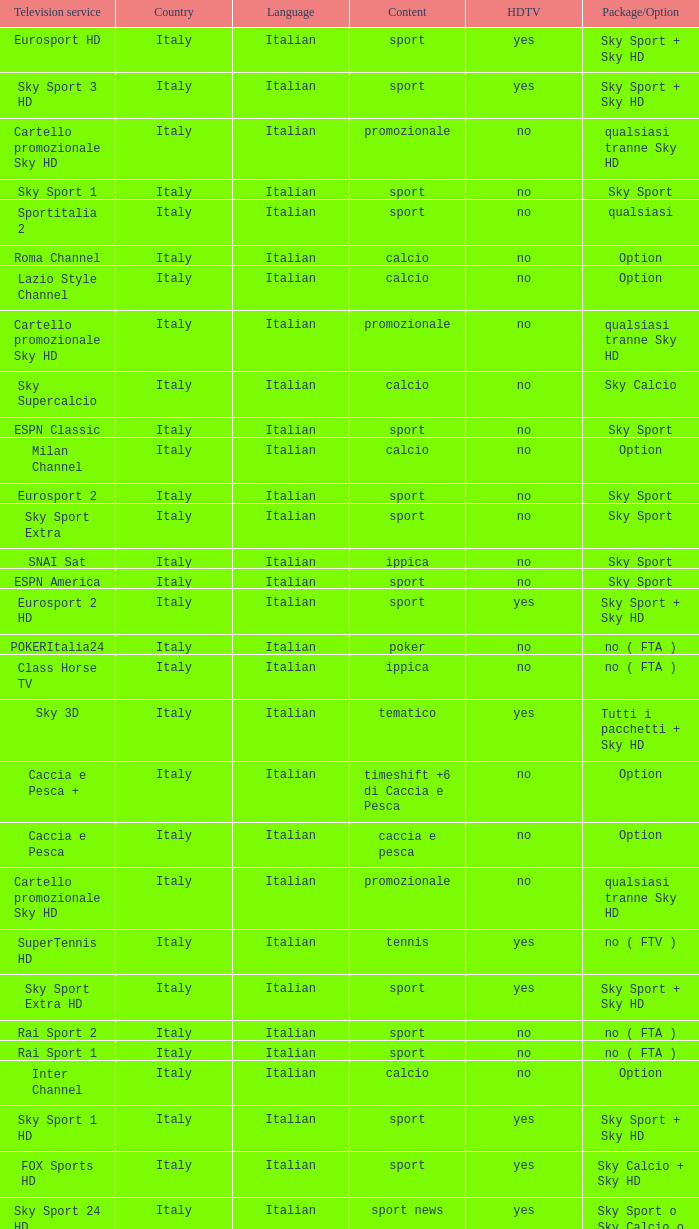What is Package/Option, when Content is Poker? No ( fta ). 